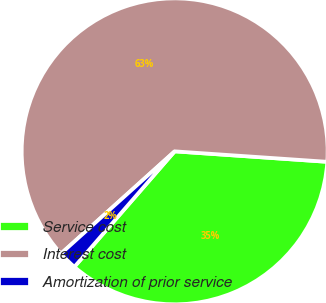<chart> <loc_0><loc_0><loc_500><loc_500><pie_chart><fcel>Service cost<fcel>Interest cost<fcel>Amortization of prior service<nl><fcel>35.29%<fcel>62.75%<fcel>1.96%<nl></chart> 